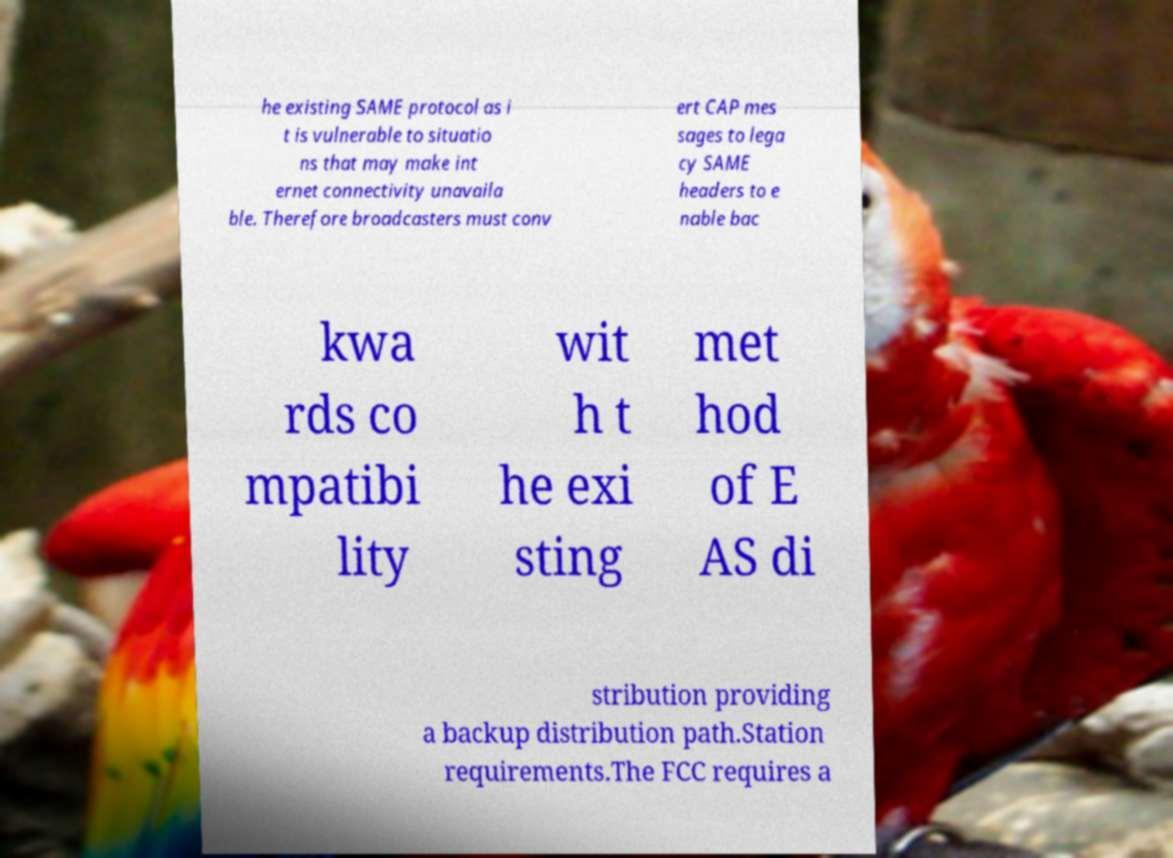Please identify and transcribe the text found in this image. he existing SAME protocol as i t is vulnerable to situatio ns that may make int ernet connectivity unavaila ble. Therefore broadcasters must conv ert CAP mes sages to lega cy SAME headers to e nable bac kwa rds co mpatibi lity wit h t he exi sting met hod of E AS di stribution providing a backup distribution path.Station requirements.The FCC requires a 